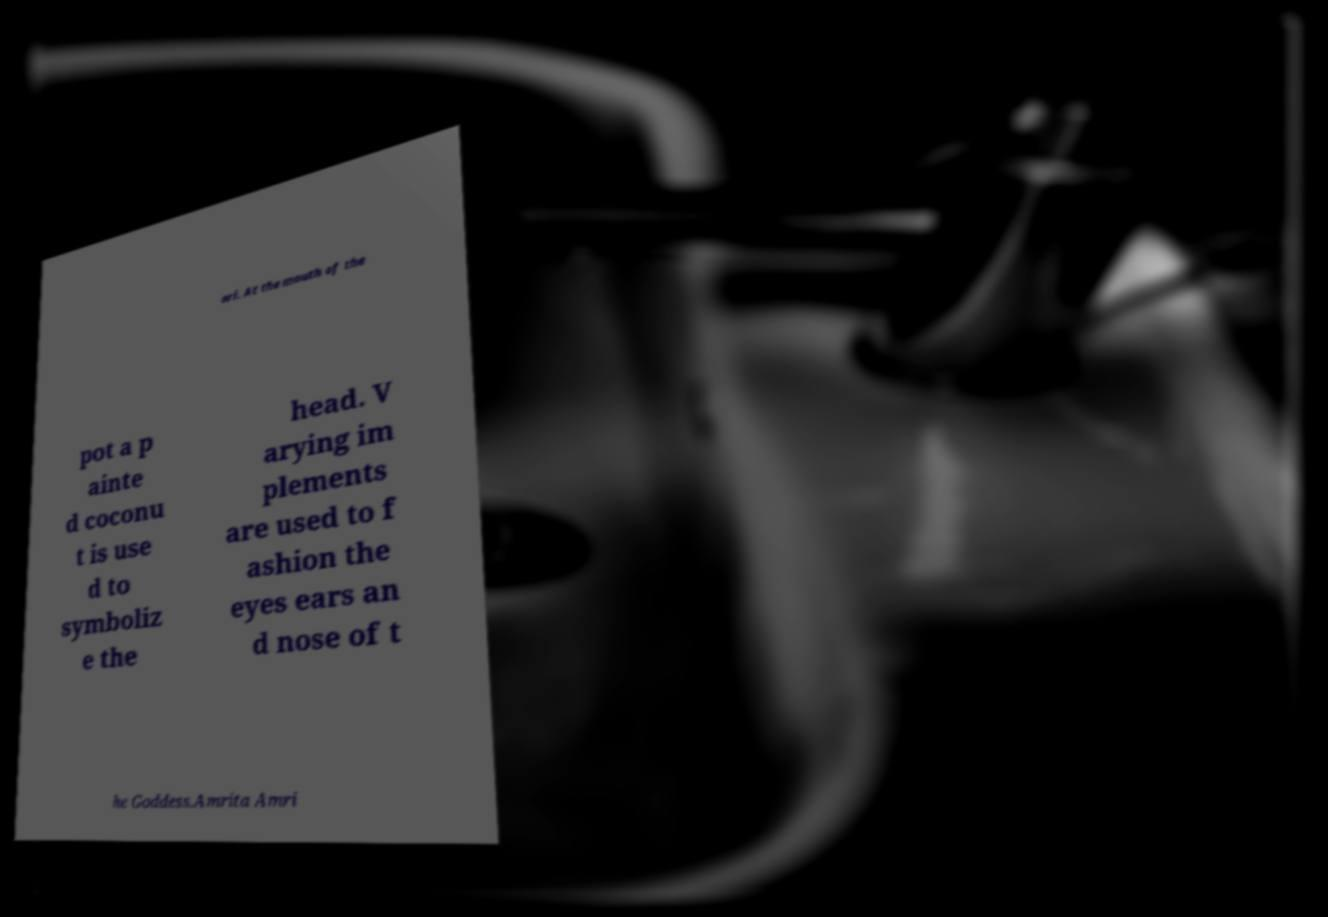Could you assist in decoding the text presented in this image and type it out clearly? ari. At the mouth of the pot a p ainte d coconu t is use d to symboliz e the head. V arying im plements are used to f ashion the eyes ears an d nose of t he Goddess.Amrita Amri 